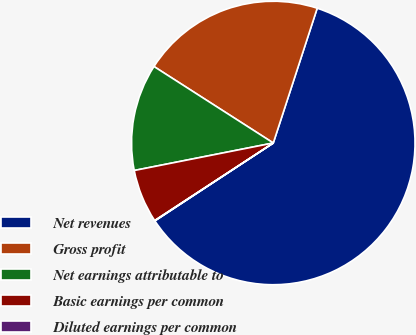<chart> <loc_0><loc_0><loc_500><loc_500><pie_chart><fcel>Net revenues<fcel>Gross profit<fcel>Net earnings attributable to<fcel>Basic earnings per common<fcel>Diluted earnings per common<nl><fcel>60.72%<fcel>20.94%<fcel>12.18%<fcel>6.11%<fcel>0.04%<nl></chart> 